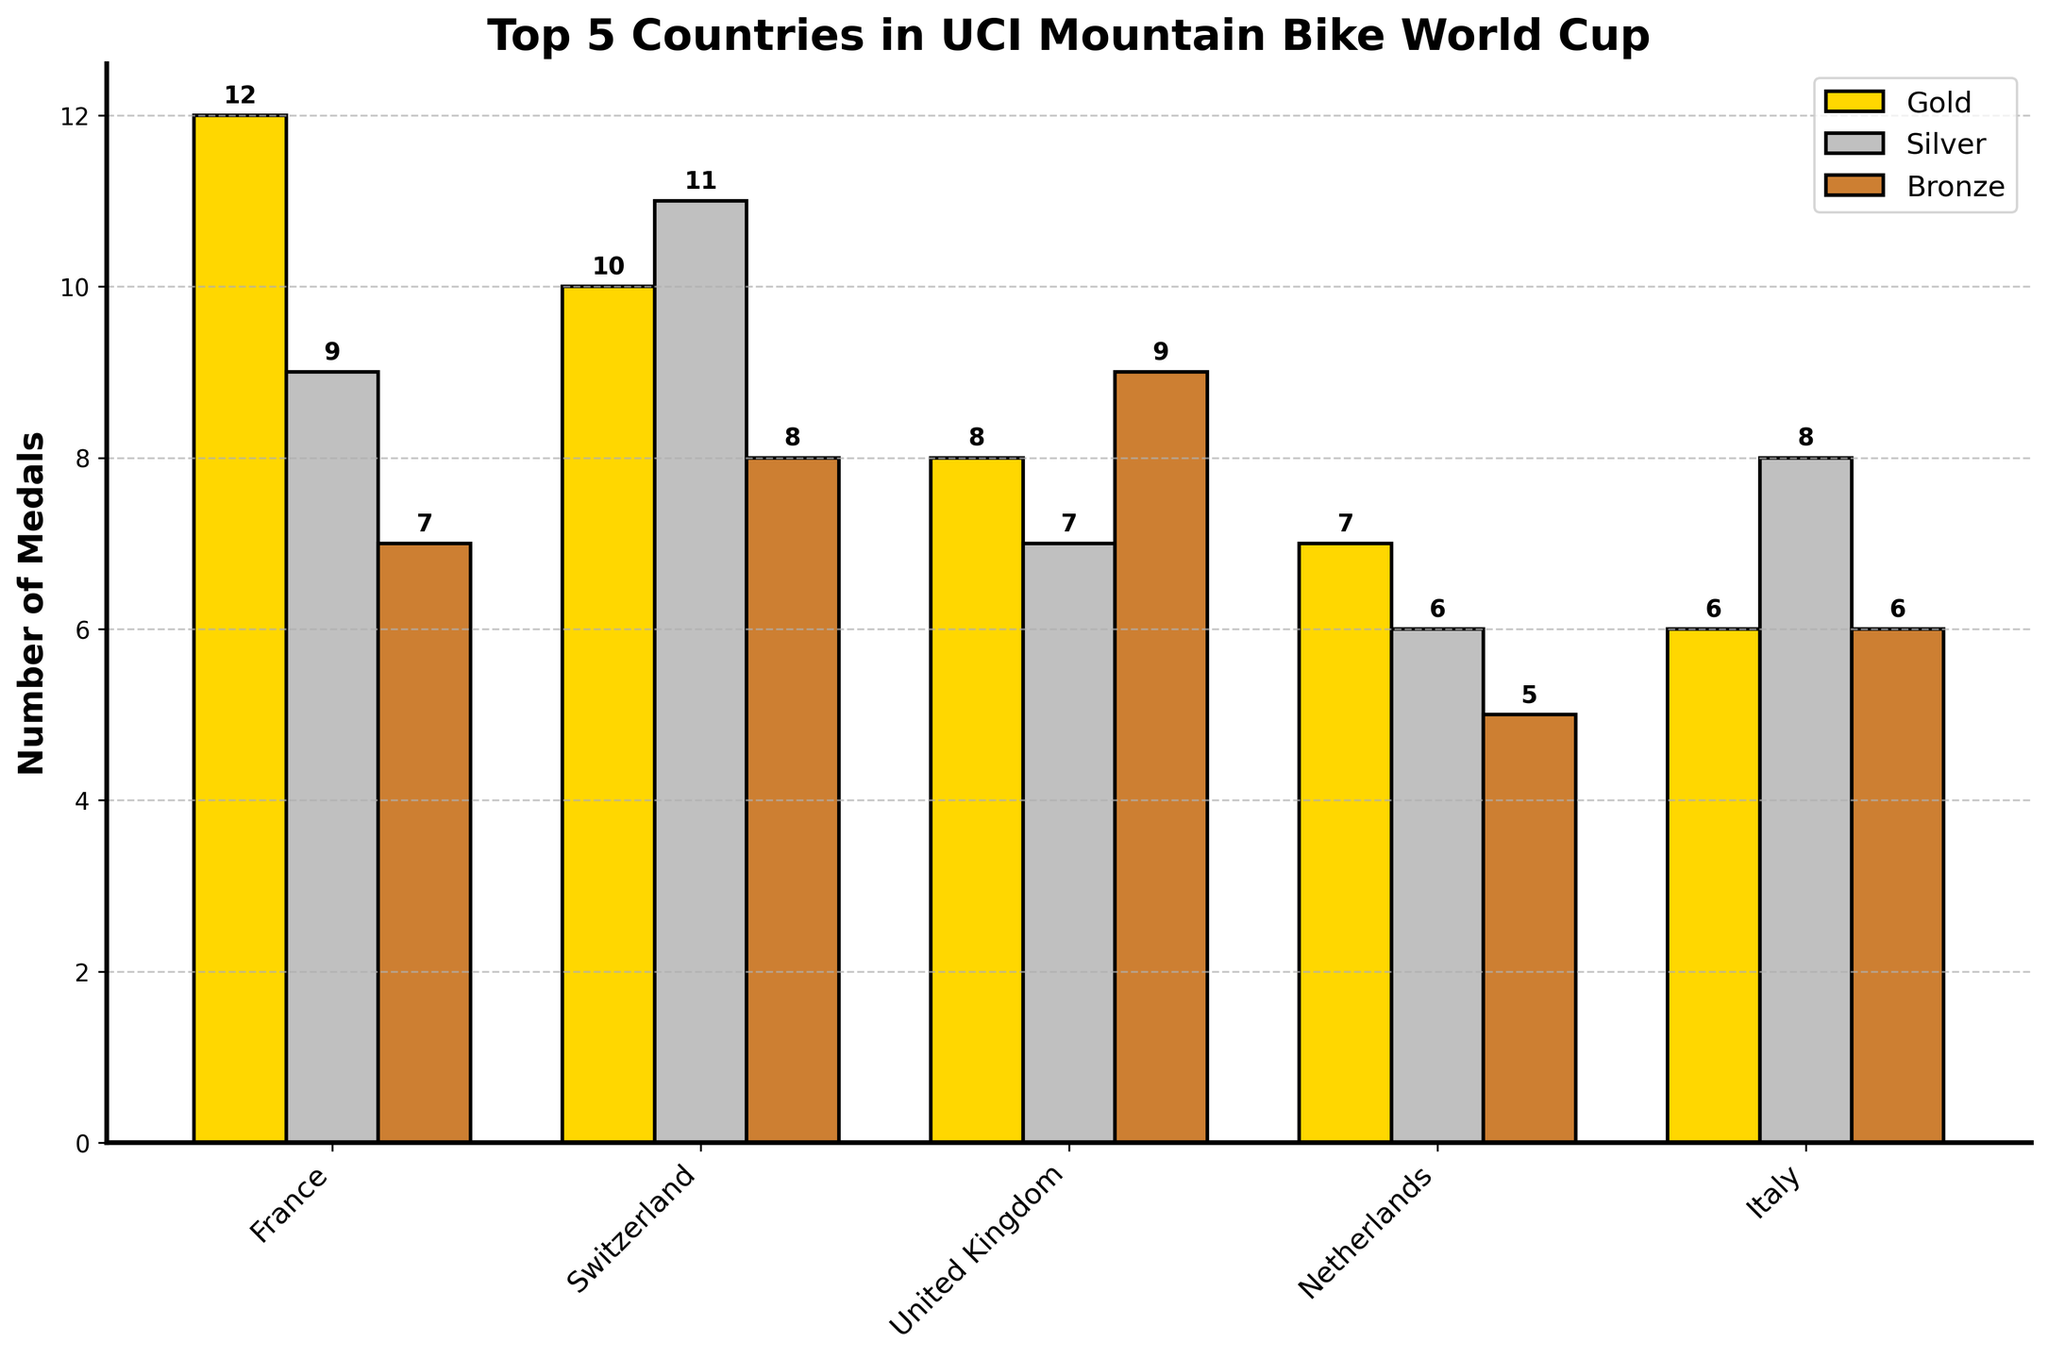What are the total number of gold, silver, and bronze medals won by Switzerland? Sum the gold, silver, and bronze medal counts for Switzerland. Gold: 10, Silver: 11, Bronze: 8. Total = 10 + 11 + 8 = 29
Answer: 29 Which country has the highest number of gold medals? Compare the gold medal counts for all countries. The highest count is 12, which belongs to France
Answer: France How many more silver medals does Italy have than the Netherlands? Subtract the number of silver medals of the Netherlands from Italy's silver medals. Italy: 8, Netherlands: 6. Difference = 8 - 6 = 2
Answer: 2 Which country has the fewest bronze medals? Compare the bronze medal counts for all countries. The fewest bronze medal count is 5, which belongs to the Netherlands
Answer: Netherlands What is the total number of medals won by France and Italy combined? Sum the total medals (gold + silver + bronze) for both France and Italy. France: 12 + 9 + 7 = 28, Italy: 6 + 8 + 6 = 20. Combined total = 28 + 20 = 48
Answer: 48 Are there any countries with an equal number of silver and bronze medals? Compare the silver and bronze medal counts for each country. The United Kingdom has 7 silver and 9 bronze, Netherlands has 6 silver and 5 bronze, and Italy has 8 silver and 6 bronze. There are no countries with equal counts.
Answer: No Which country has the most balanced distribution of gold, silver, and bronze medals? (Balance defined as the smallest range between the highest and lowest counts) Calculate the range (difference between highest and lowest counts) for each country. France: 12-7=5, Switzerland: 11-8=3, United Kingdom: 9-7=2, Netherlands: 7-5=2, Italy: 8-6=2. The United Kingdom, Netherlands, and Italy have the smallest range of 2.
Answer: United Kingdom, Netherlands, Italy Which country has the lowest total number of medals? Add up the total medals (gold + silver + bronze) for each country and find the minimum. France: 28, Switzerland: 29, United Kingdom: 24, Netherlands: 18, Italy: 20. The Netherlands has the fewest total medals.
Answer: Netherlands How many bronze medals do the top two gold medal-winning countries have together? Identify the top two gold medal-winning countries (France with 12 and Switzerland with 10), and sum their bronze medal counts. France: 7, Switzerland: 8. Total= 7 + 8 = 15
Answer: 15 